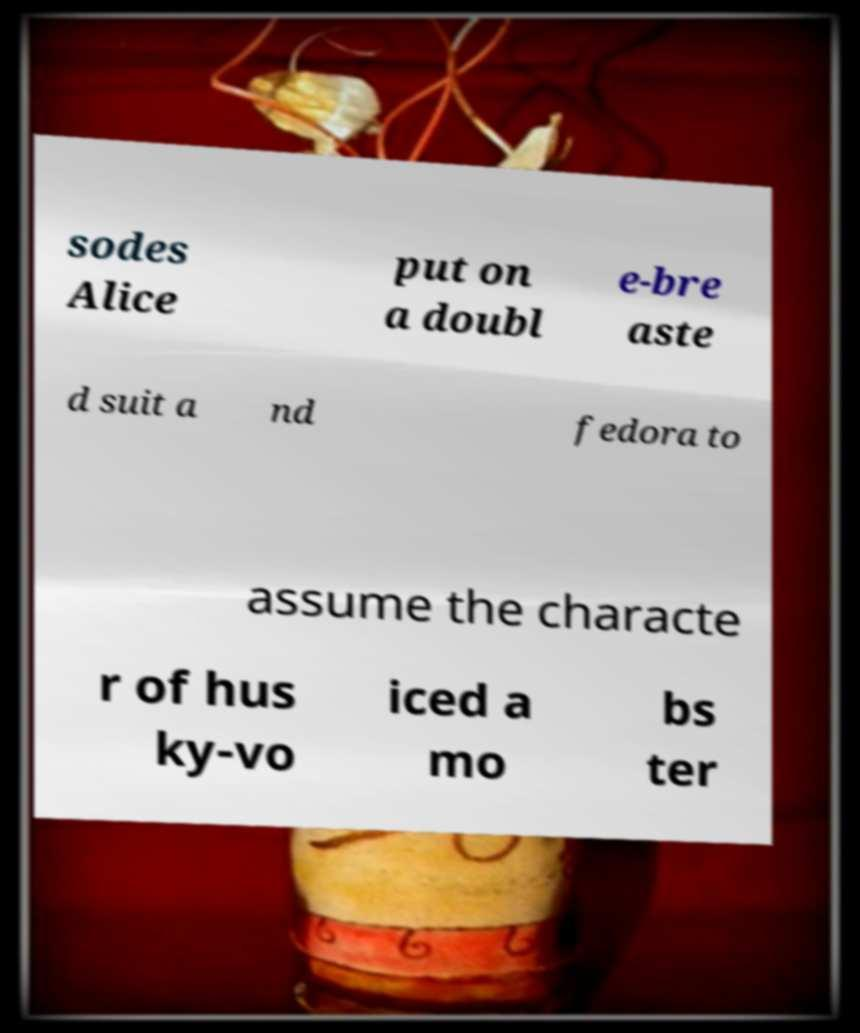There's text embedded in this image that I need extracted. Can you transcribe it verbatim? sodes Alice put on a doubl e-bre aste d suit a nd fedora to assume the characte r of hus ky-vo iced a mo bs ter 